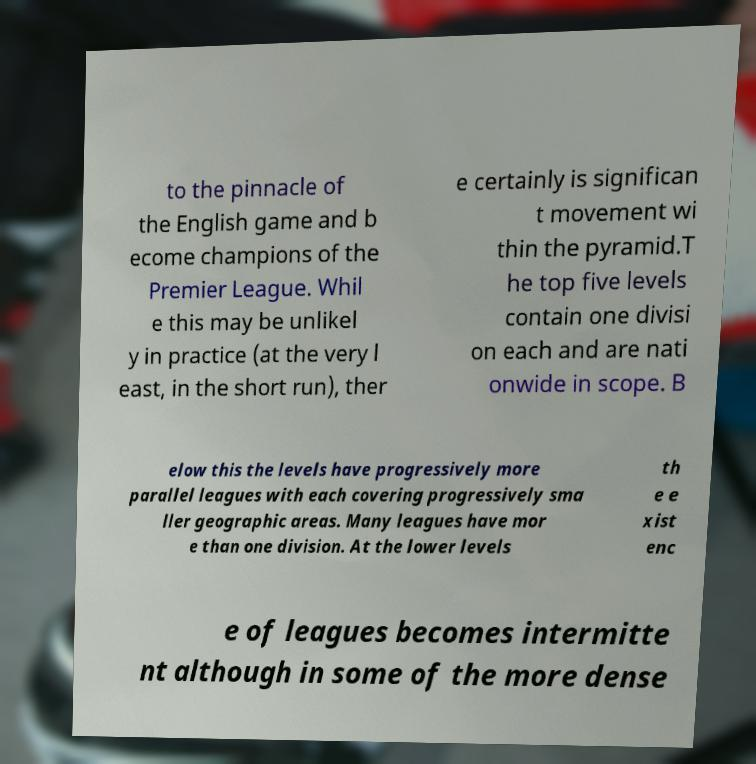Could you extract and type out the text from this image? to the pinnacle of the English game and b ecome champions of the Premier League. Whil e this may be unlikel y in practice (at the very l east, in the short run), ther e certainly is significan t movement wi thin the pyramid.T he top five levels contain one divisi on each and are nati onwide in scope. B elow this the levels have progressively more parallel leagues with each covering progressively sma ller geographic areas. Many leagues have mor e than one division. At the lower levels th e e xist enc e of leagues becomes intermitte nt although in some of the more dense 